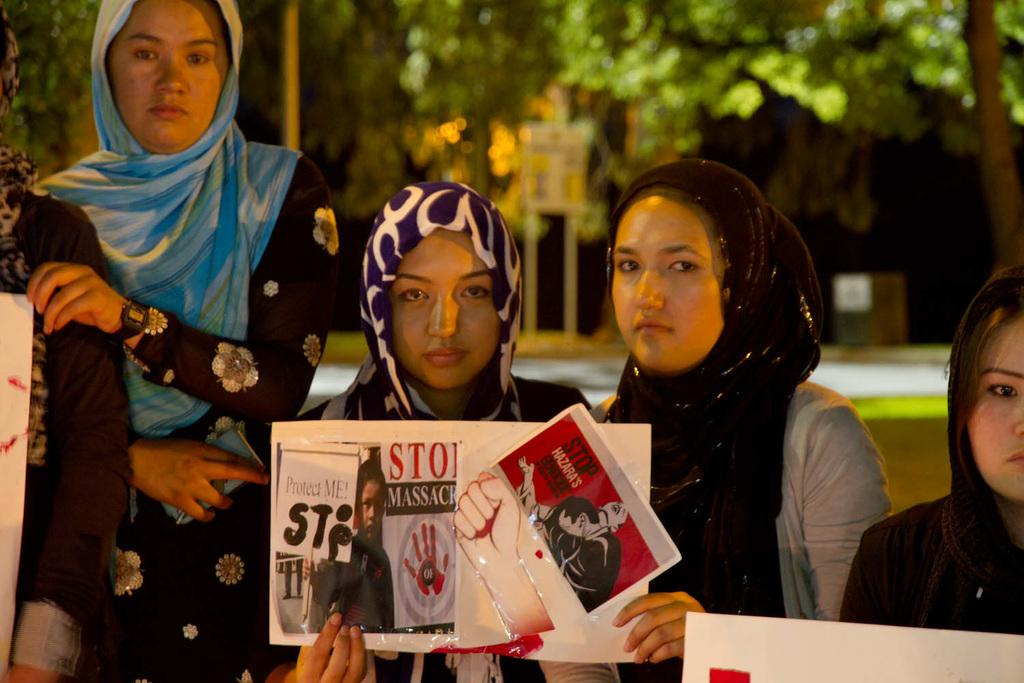What is the main subject of the image? The main subject of the image is people. What are the people holding in their hands? The people are holding boards in their hands. What can be seen in the background of the image? There are trees and buildings in the background of the image. What type of notebook is being used by the people in the image? There is no notebook present in the image; the people are holding boards in their hands. 